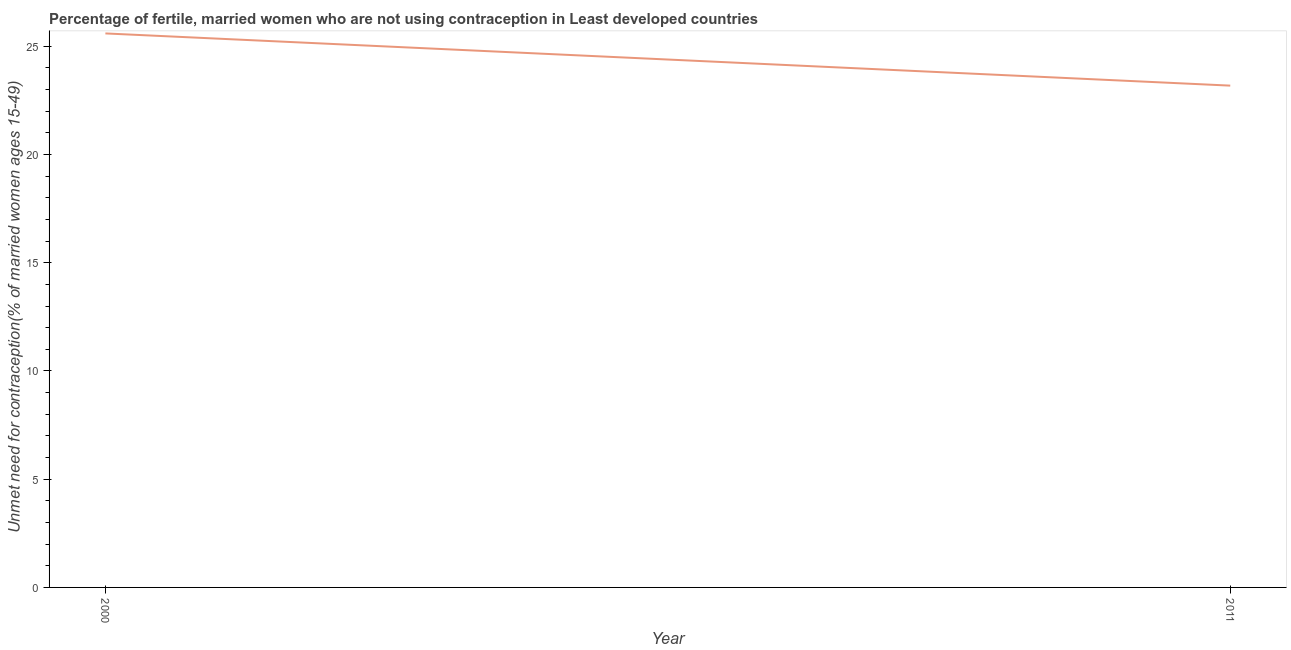What is the number of married women who are not using contraception in 2000?
Your response must be concise. 25.6. Across all years, what is the maximum number of married women who are not using contraception?
Ensure brevity in your answer.  25.6. Across all years, what is the minimum number of married women who are not using contraception?
Ensure brevity in your answer.  23.18. What is the sum of the number of married women who are not using contraception?
Keep it short and to the point. 48.78. What is the difference between the number of married women who are not using contraception in 2000 and 2011?
Offer a very short reply. 2.41. What is the average number of married women who are not using contraception per year?
Offer a terse response. 24.39. What is the median number of married women who are not using contraception?
Provide a short and direct response. 24.39. In how many years, is the number of married women who are not using contraception greater than 12 %?
Ensure brevity in your answer.  2. What is the ratio of the number of married women who are not using contraception in 2000 to that in 2011?
Provide a short and direct response. 1.1. Is the number of married women who are not using contraception in 2000 less than that in 2011?
Your response must be concise. No. In how many years, is the number of married women who are not using contraception greater than the average number of married women who are not using contraception taken over all years?
Provide a succinct answer. 1. How many years are there in the graph?
Make the answer very short. 2. Are the values on the major ticks of Y-axis written in scientific E-notation?
Provide a succinct answer. No. Does the graph contain any zero values?
Make the answer very short. No. What is the title of the graph?
Your answer should be very brief. Percentage of fertile, married women who are not using contraception in Least developed countries. What is the label or title of the Y-axis?
Your answer should be very brief.  Unmet need for contraception(% of married women ages 15-49). What is the  Unmet need for contraception(% of married women ages 15-49) of 2000?
Offer a very short reply. 25.6. What is the  Unmet need for contraception(% of married women ages 15-49) of 2011?
Provide a short and direct response. 23.18. What is the difference between the  Unmet need for contraception(% of married women ages 15-49) in 2000 and 2011?
Your answer should be compact. 2.41. What is the ratio of the  Unmet need for contraception(% of married women ages 15-49) in 2000 to that in 2011?
Ensure brevity in your answer.  1.1. 